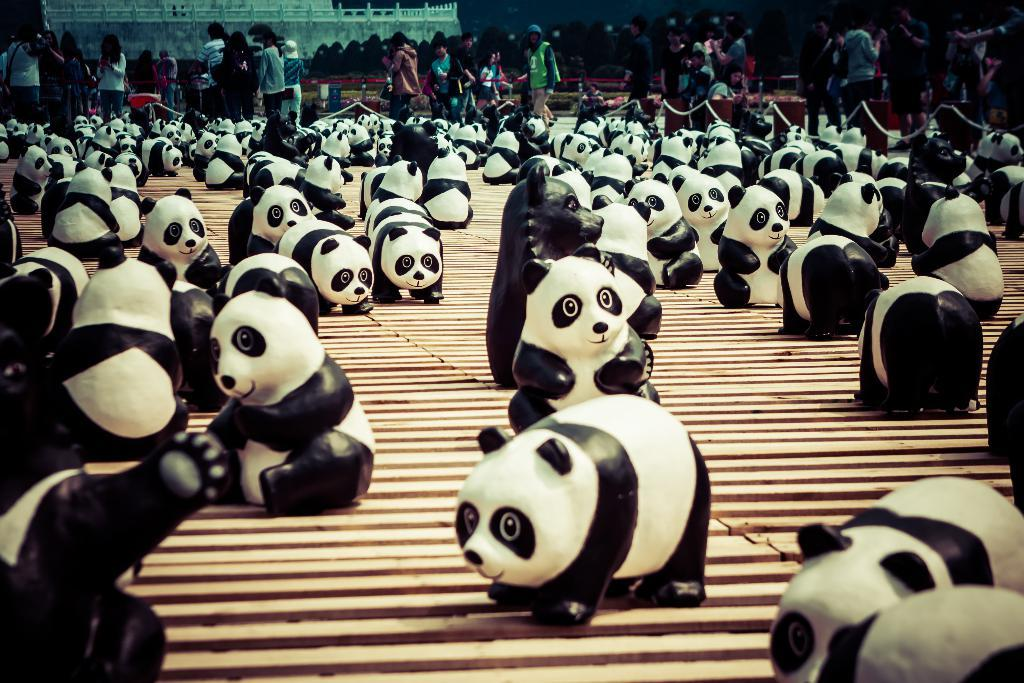What is the main subject of the image? The main subject of the image is depictions of pandas in the center. Can you describe the people in the image? There are people walking in the background of the image. What type of roll is being prepared by the uncle in the image? There is no uncle or roll preparation present in the image. 